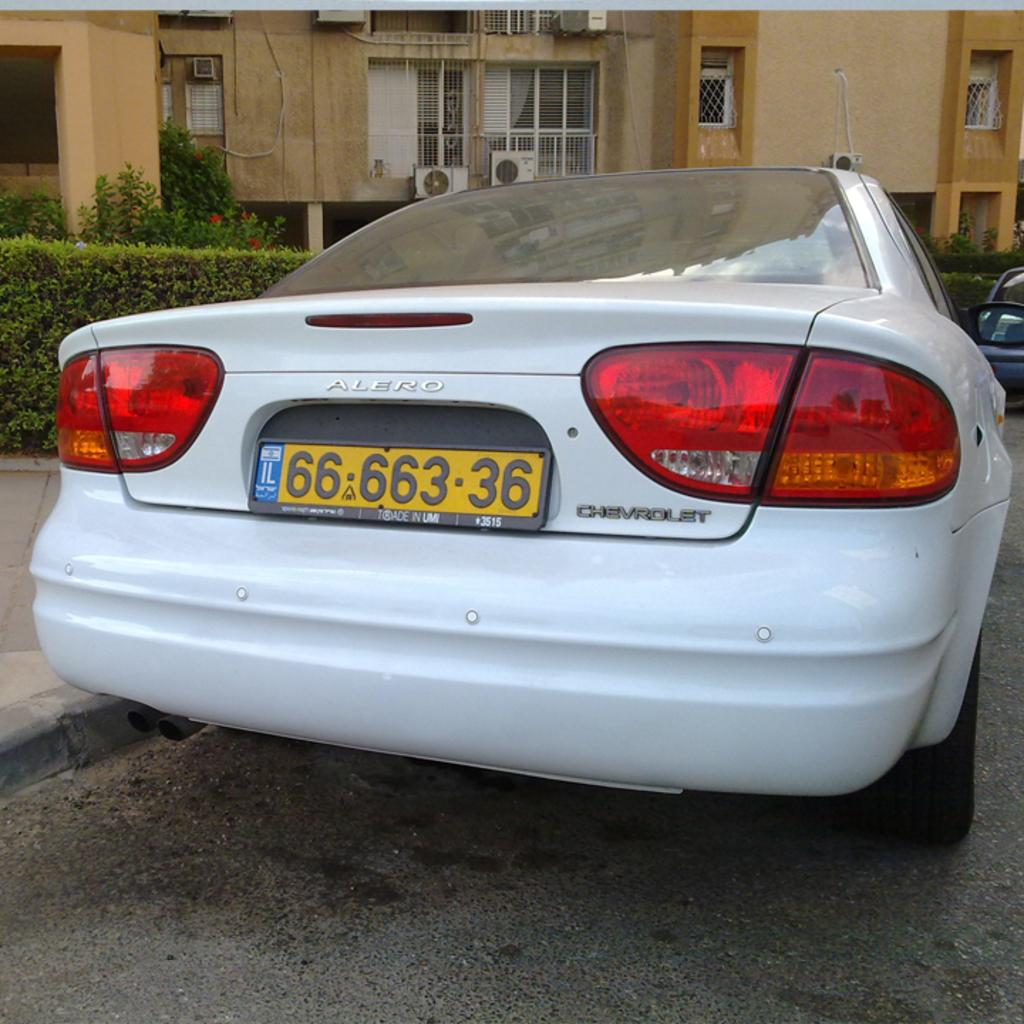What is the main subject in the middle of the picture? There is a car in the middle of the picture. What can be seen in the background of the picture? There is a building in the background of the picture. What color is the bath in the picture? There is no bath present in the picture; it only features a car and a building in the background. 